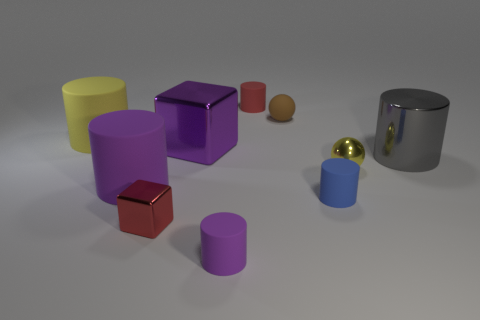Is there a tiny brown cylinder that has the same material as the gray object?
Offer a very short reply. No. What color is the large shiny object that is the same shape as the blue rubber thing?
Your answer should be very brief. Gray. Are there fewer small brown rubber objects in front of the small shiny sphere than tiny purple cylinders behind the large purple matte thing?
Ensure brevity in your answer.  No. How many other things are there of the same shape as the blue object?
Your answer should be very brief. 5. Is the number of small yellow metal objects to the right of the metal cylinder less than the number of small metallic things?
Your answer should be compact. Yes. What is the material of the big cylinder right of the large purple rubber cylinder?
Keep it short and to the point. Metal. How many other things are there of the same size as the red rubber cylinder?
Offer a terse response. 5. Is the number of shiny blocks less than the number of yellow cubes?
Your answer should be very brief. No. What is the shape of the tiny yellow object?
Make the answer very short. Sphere. Does the rubber cylinder that is right of the small brown sphere have the same color as the big shiny cylinder?
Offer a very short reply. No. 